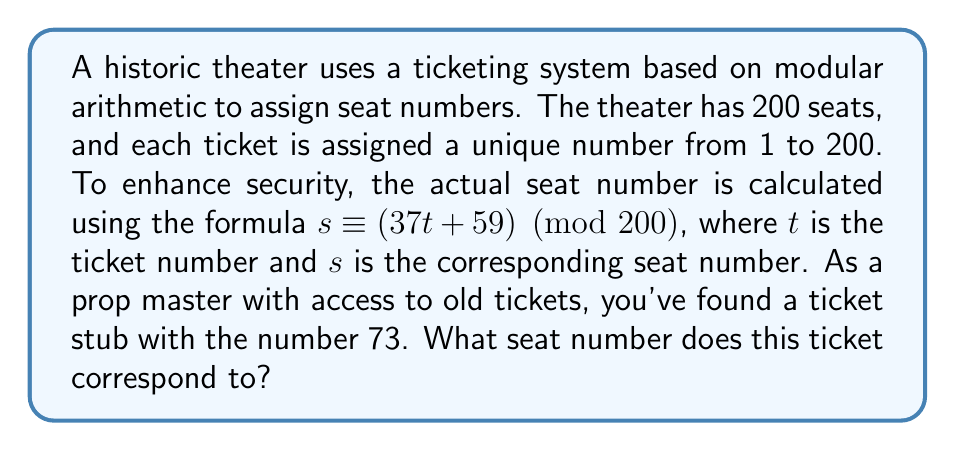Provide a solution to this math problem. To solve this problem, we'll use the given formula and apply modular arithmetic:

1) The formula is: $s \equiv (37t + 59) \pmod{200}$

2) We're given that $t = 73$ (the ticket number)

3) Let's substitute this into our formula:
   $s \equiv (37 \cdot 73 + 59) \pmod{200}$

4) First, let's multiply 37 and 73:
   $37 \cdot 73 = 2701$

5) Now our equation looks like this:
   $s \equiv (2701 + 59) \pmod{200}$

6) Add 2701 and 59:
   $s \equiv 2760 \pmod{200}$

7) To solve this, we need to find the remainder when 2760 is divided by 200:
   $2760 \div 200 = 13$ remainder $160$

8) Therefore:
   $s \equiv 160 \pmod{200}$

So, the seat number corresponding to ticket number 73 is 160.
Answer: 160 